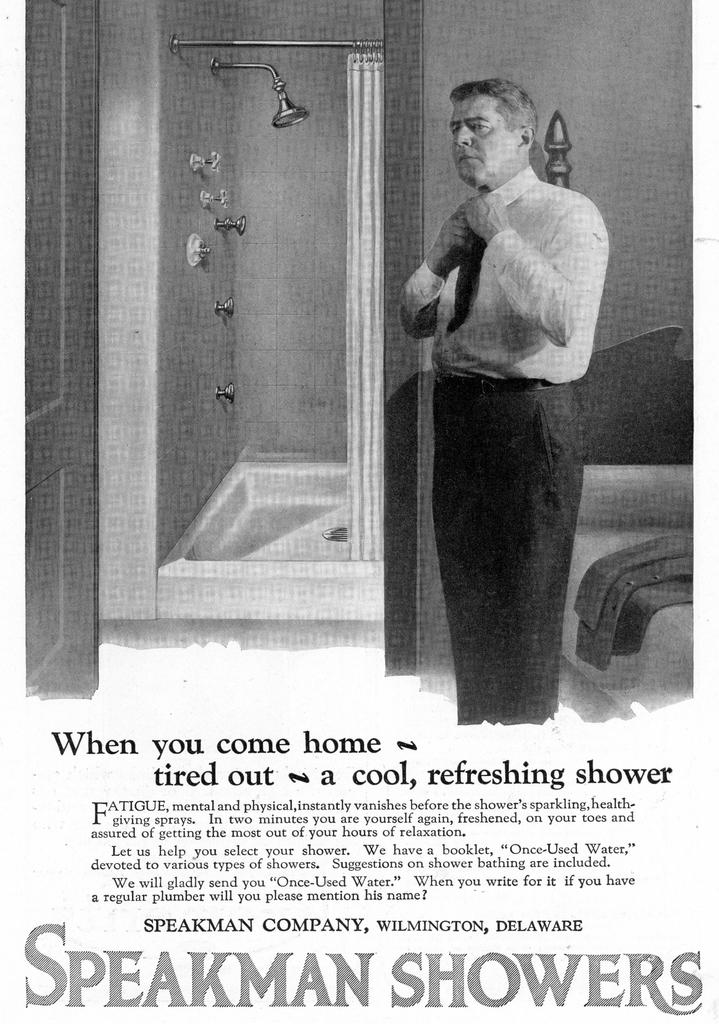Provide a one-sentence caption for the provided image. an ad for speakman showers with a man in a tie. 